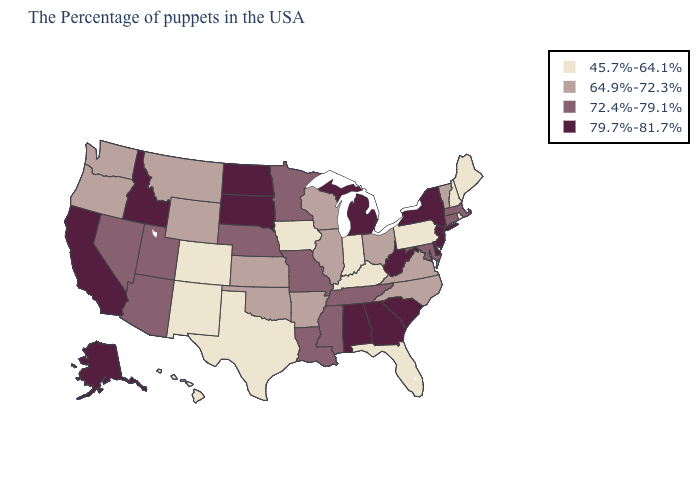What is the highest value in the South ?
Short answer required. 79.7%-81.7%. Among the states that border Oklahoma , which have the highest value?
Quick response, please. Missouri. What is the value of Rhode Island?
Give a very brief answer. 45.7%-64.1%. Does Louisiana have the same value as Utah?
Quick response, please. Yes. Among the states that border Virginia , which have the highest value?
Short answer required. West Virginia. Name the states that have a value in the range 79.7%-81.7%?
Quick response, please. New York, New Jersey, Delaware, South Carolina, West Virginia, Georgia, Michigan, Alabama, South Dakota, North Dakota, Idaho, California, Alaska. What is the value of Arizona?
Answer briefly. 72.4%-79.1%. Does Illinois have a higher value than Florida?
Write a very short answer. Yes. Name the states that have a value in the range 64.9%-72.3%?
Short answer required. Vermont, Virginia, North Carolina, Ohio, Wisconsin, Illinois, Arkansas, Kansas, Oklahoma, Wyoming, Montana, Washington, Oregon. What is the value of Hawaii?
Short answer required. 45.7%-64.1%. Among the states that border Texas , which have the lowest value?
Concise answer only. New Mexico. Does Massachusetts have the same value as Nevada?
Be succinct. Yes. Does Alabama have the highest value in the South?
Write a very short answer. Yes. What is the value of Montana?
Quick response, please. 64.9%-72.3%. Among the states that border Montana , which have the lowest value?
Keep it brief. Wyoming. 